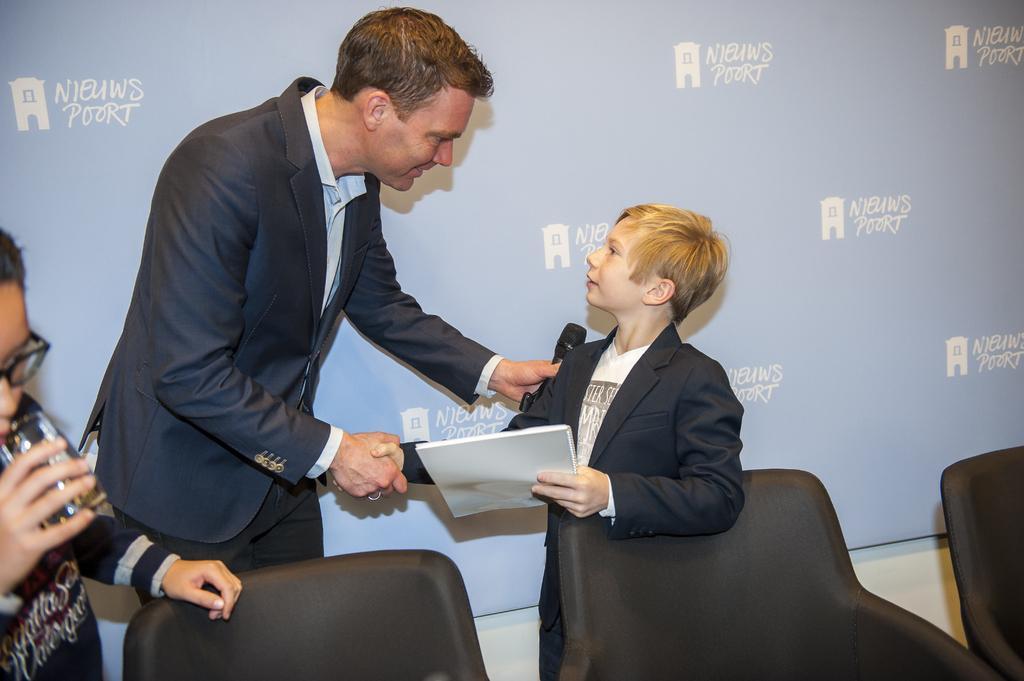In one or two sentences, can you explain what this image depicts? In this image I can see a man wearing suit, standing, shaking hands with a boy. This boys also wearing black color suit and holding a book in the hand. Both are looking at each other. I can see a mike in man's hand. On the left side, I can see another person is holding a glass in hand. At the bottom of the image I can see three chairs. In the background there is a board. 